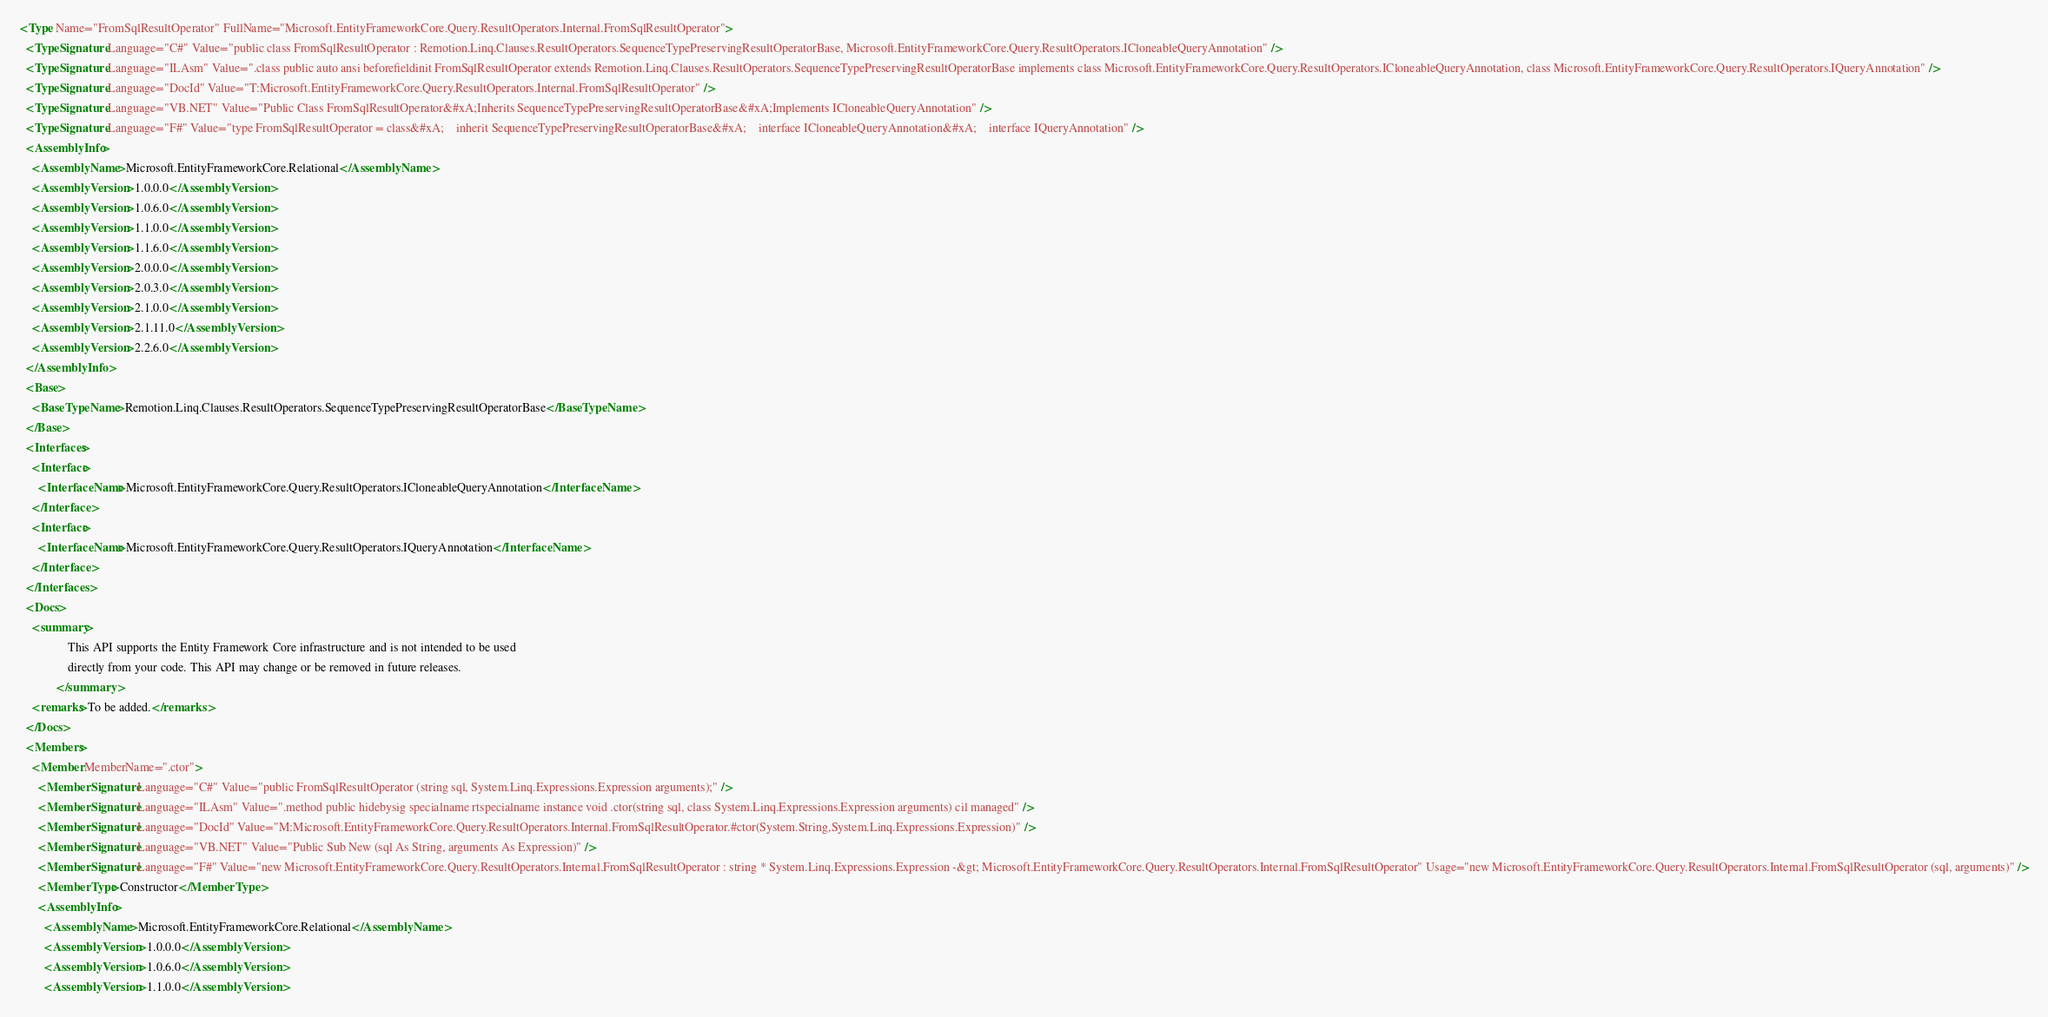Convert code to text. <code><loc_0><loc_0><loc_500><loc_500><_XML_><Type Name="FromSqlResultOperator" FullName="Microsoft.EntityFrameworkCore.Query.ResultOperators.Internal.FromSqlResultOperator">
  <TypeSignature Language="C#" Value="public class FromSqlResultOperator : Remotion.Linq.Clauses.ResultOperators.SequenceTypePreservingResultOperatorBase, Microsoft.EntityFrameworkCore.Query.ResultOperators.ICloneableQueryAnnotation" />
  <TypeSignature Language="ILAsm" Value=".class public auto ansi beforefieldinit FromSqlResultOperator extends Remotion.Linq.Clauses.ResultOperators.SequenceTypePreservingResultOperatorBase implements class Microsoft.EntityFrameworkCore.Query.ResultOperators.ICloneableQueryAnnotation, class Microsoft.EntityFrameworkCore.Query.ResultOperators.IQueryAnnotation" />
  <TypeSignature Language="DocId" Value="T:Microsoft.EntityFrameworkCore.Query.ResultOperators.Internal.FromSqlResultOperator" />
  <TypeSignature Language="VB.NET" Value="Public Class FromSqlResultOperator&#xA;Inherits SequenceTypePreservingResultOperatorBase&#xA;Implements ICloneableQueryAnnotation" />
  <TypeSignature Language="F#" Value="type FromSqlResultOperator = class&#xA;    inherit SequenceTypePreservingResultOperatorBase&#xA;    interface ICloneableQueryAnnotation&#xA;    interface IQueryAnnotation" />
  <AssemblyInfo>
    <AssemblyName>Microsoft.EntityFrameworkCore.Relational</AssemblyName>
    <AssemblyVersion>1.0.0.0</AssemblyVersion>
    <AssemblyVersion>1.0.6.0</AssemblyVersion>
    <AssemblyVersion>1.1.0.0</AssemblyVersion>
    <AssemblyVersion>1.1.6.0</AssemblyVersion>
    <AssemblyVersion>2.0.0.0</AssemblyVersion>
    <AssemblyVersion>2.0.3.0</AssemblyVersion>
    <AssemblyVersion>2.1.0.0</AssemblyVersion>
    <AssemblyVersion>2.1.11.0</AssemblyVersion>
    <AssemblyVersion>2.2.6.0</AssemblyVersion>
  </AssemblyInfo>
  <Base>
    <BaseTypeName>Remotion.Linq.Clauses.ResultOperators.SequenceTypePreservingResultOperatorBase</BaseTypeName>
  </Base>
  <Interfaces>
    <Interface>
      <InterfaceName>Microsoft.EntityFrameworkCore.Query.ResultOperators.ICloneableQueryAnnotation</InterfaceName>
    </Interface>
    <Interface>
      <InterfaceName>Microsoft.EntityFrameworkCore.Query.ResultOperators.IQueryAnnotation</InterfaceName>
    </Interface>
  </Interfaces>
  <Docs>
    <summary>
                This API supports the Entity Framework Core infrastructure and is not intended to be used
                directly from your code. This API may change or be removed in future releases.
            </summary>
    <remarks>To be added.</remarks>
  </Docs>
  <Members>
    <Member MemberName=".ctor">
      <MemberSignature Language="C#" Value="public FromSqlResultOperator (string sql, System.Linq.Expressions.Expression arguments);" />
      <MemberSignature Language="ILAsm" Value=".method public hidebysig specialname rtspecialname instance void .ctor(string sql, class System.Linq.Expressions.Expression arguments) cil managed" />
      <MemberSignature Language="DocId" Value="M:Microsoft.EntityFrameworkCore.Query.ResultOperators.Internal.FromSqlResultOperator.#ctor(System.String,System.Linq.Expressions.Expression)" />
      <MemberSignature Language="VB.NET" Value="Public Sub New (sql As String, arguments As Expression)" />
      <MemberSignature Language="F#" Value="new Microsoft.EntityFrameworkCore.Query.ResultOperators.Internal.FromSqlResultOperator : string * System.Linq.Expressions.Expression -&gt; Microsoft.EntityFrameworkCore.Query.ResultOperators.Internal.FromSqlResultOperator" Usage="new Microsoft.EntityFrameworkCore.Query.ResultOperators.Internal.FromSqlResultOperator (sql, arguments)" />
      <MemberType>Constructor</MemberType>
      <AssemblyInfo>
        <AssemblyName>Microsoft.EntityFrameworkCore.Relational</AssemblyName>
        <AssemblyVersion>1.0.0.0</AssemblyVersion>
        <AssemblyVersion>1.0.6.0</AssemblyVersion>
        <AssemblyVersion>1.1.0.0</AssemblyVersion></code> 